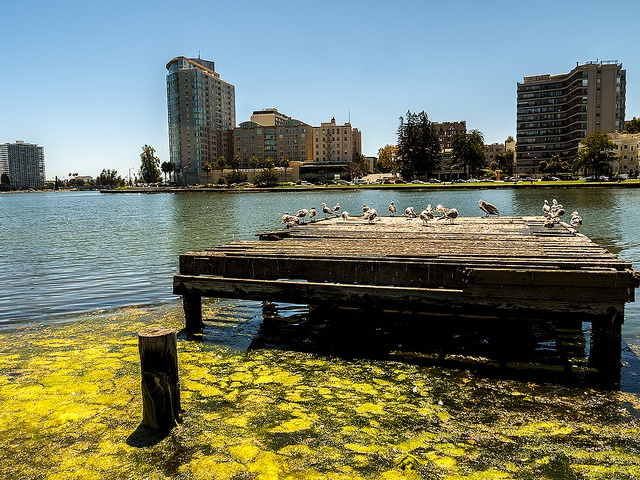Describe the objects in this image and their specific colors. I can see bird in lightblue, black, ivory, gray, and darkgray tones, bird in lightblue, black, darkgray, maroon, and gray tones, bird in lightblue, ivory, black, and tan tones, bird in lightblue, white, darkgray, black, and gray tones, and bird in lightblue, black, ivory, darkgray, and tan tones in this image. 